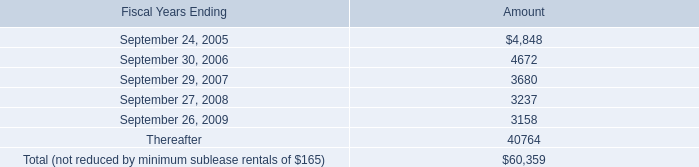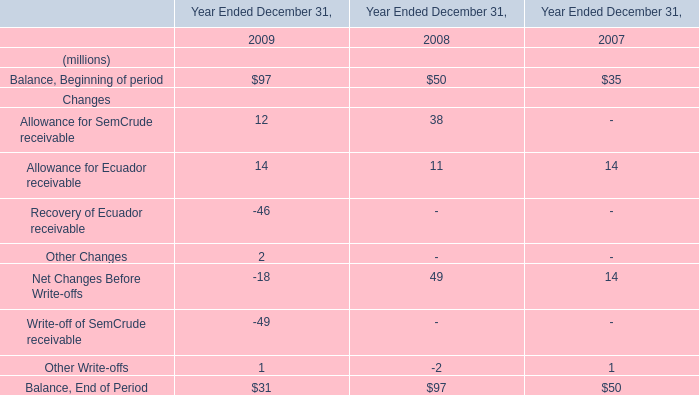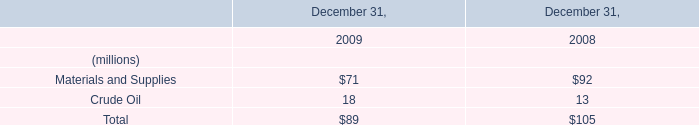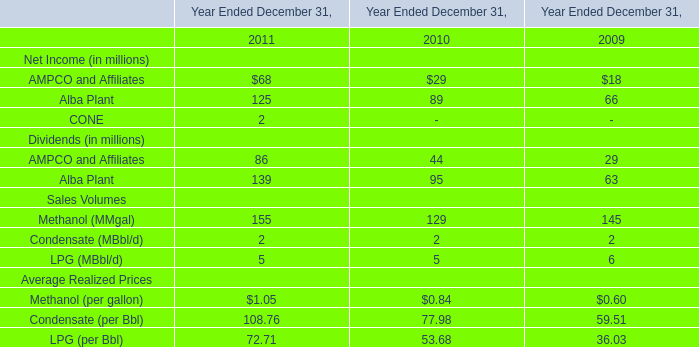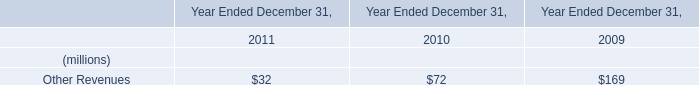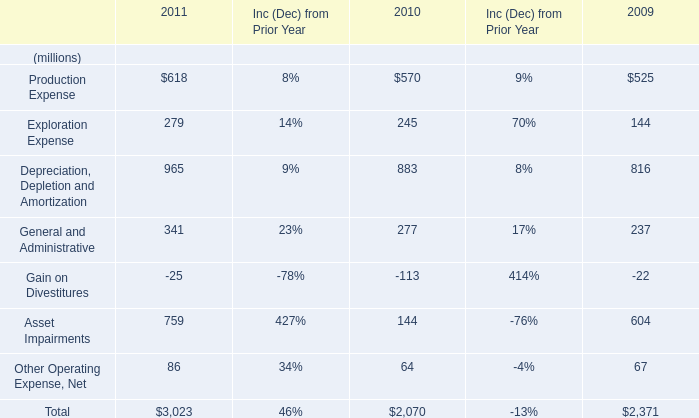If Methanol (MMgal) develops with the same increasing rate in 2011, what will it reach in 2012? (in million) 
Computations: ((1 + ((155 - 129) / 129)) * 155)
Answer: 186.24031. 